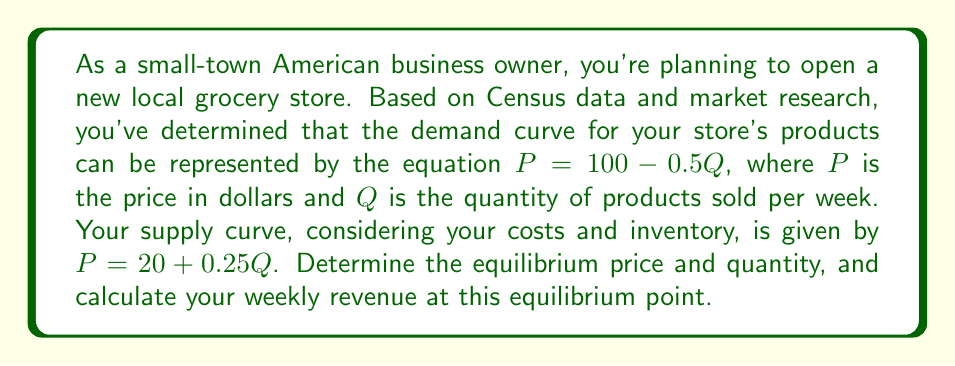Could you help me with this problem? To solve this problem, we need to follow these steps:

1. Find the equilibrium point by equating the demand and supply curves:
   
   Demand: $P = 100 - 0.5Q$
   Supply: $P = 20 + 0.25Q$
   
   At equilibrium: $100 - 0.5Q = 20 + 0.25Q$

2. Solve for Q:
   
   $100 - 0.5Q = 20 + 0.25Q$
   $80 = 0.75Q$
   $Q = 80 / 0.75 = 106.67$

3. Round Q to the nearest whole number:
   
   $Q = 107$ products per week

4. Calculate the equilibrium price by substituting Q into either the demand or supply equation:
   
   Using demand equation: $P = 100 - 0.5(107) = 46.5$

5. Calculate the weekly revenue:
   
   Revenue = Price × Quantity
   $R = 46.5 × 107 = 4,975.5$

Therefore, the equilibrium price is $46.50, the equilibrium quantity is 107 products per week, and the weekly revenue at this equilibrium point is $4,975.50.
Answer: Equilibrium price: $46.50
Equilibrium quantity: 107 products per week
Weekly revenue: $4,975.50 